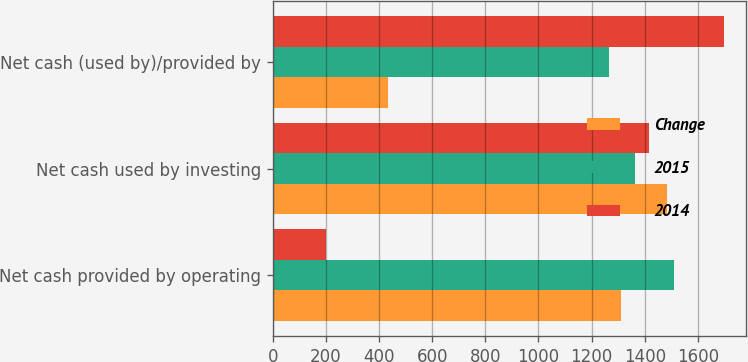Convert chart. <chart><loc_0><loc_0><loc_500><loc_500><stacked_bar_chart><ecel><fcel>Net cash provided by operating<fcel>Net cash used by investing<fcel>Net cash (used by)/provided by<nl><fcel>Change<fcel>1309<fcel>1485<fcel>432<nl><fcel>2015<fcel>1510<fcel>1363.5<fcel>1265<nl><fcel>2014<fcel>201<fcel>1418<fcel>1697<nl></chart> 